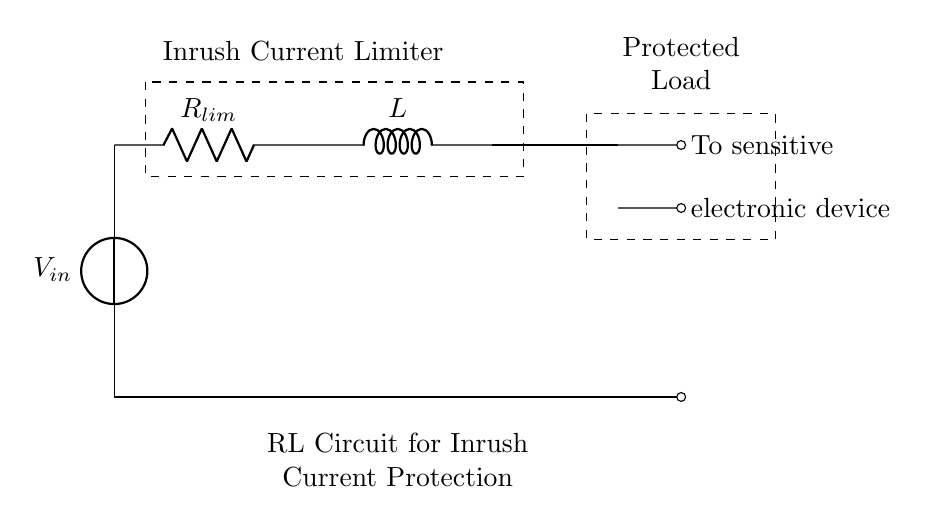What is the type of circuit shown? The circuit is an RL circuit, which consists of a resistor and an inductor. This is indicated by the presence of both components connected in a series configuration.
Answer: RL circuit What is the purpose of the resistor in this circuit? The resistor limits the inrush current when the sensitive electronic device is connected to the power supply. It acts to reduce the sudden spike of current that can damage the device.
Answer: Inrush current limiting What is the role of the inductor in this circuit? The inductor opposes changes in current, contributing to the overall limitation of inrush current into the protected load by providing reactance that increases with frequency.
Answer: Current opposition What does the dashed rectangle represent in the diagram? The dashed rectangle indicates the "Protected Load," which encompasses the sensitive electronic devices being safeguarded from excessive current.
Answer: Protected load How is the sensitive electronic device connected in the circuit? The sensitive electronic device is connected to the end of the series arrangement of the resistor and inductor, indicated by the short lines leading to the device labels.
Answer: Series connection What is the input voltage source labeled as? The input voltage source is labeled as V_in, designating the voltage supplied to the circuit for operation.
Answer: V_in What happens to the inrush current when the device is first powered on? When the device is first powered on, the inrush current is limited due to both the resistance and the inductance, preventing high currents that could potentially harm the circuit.
Answer: Limited current 